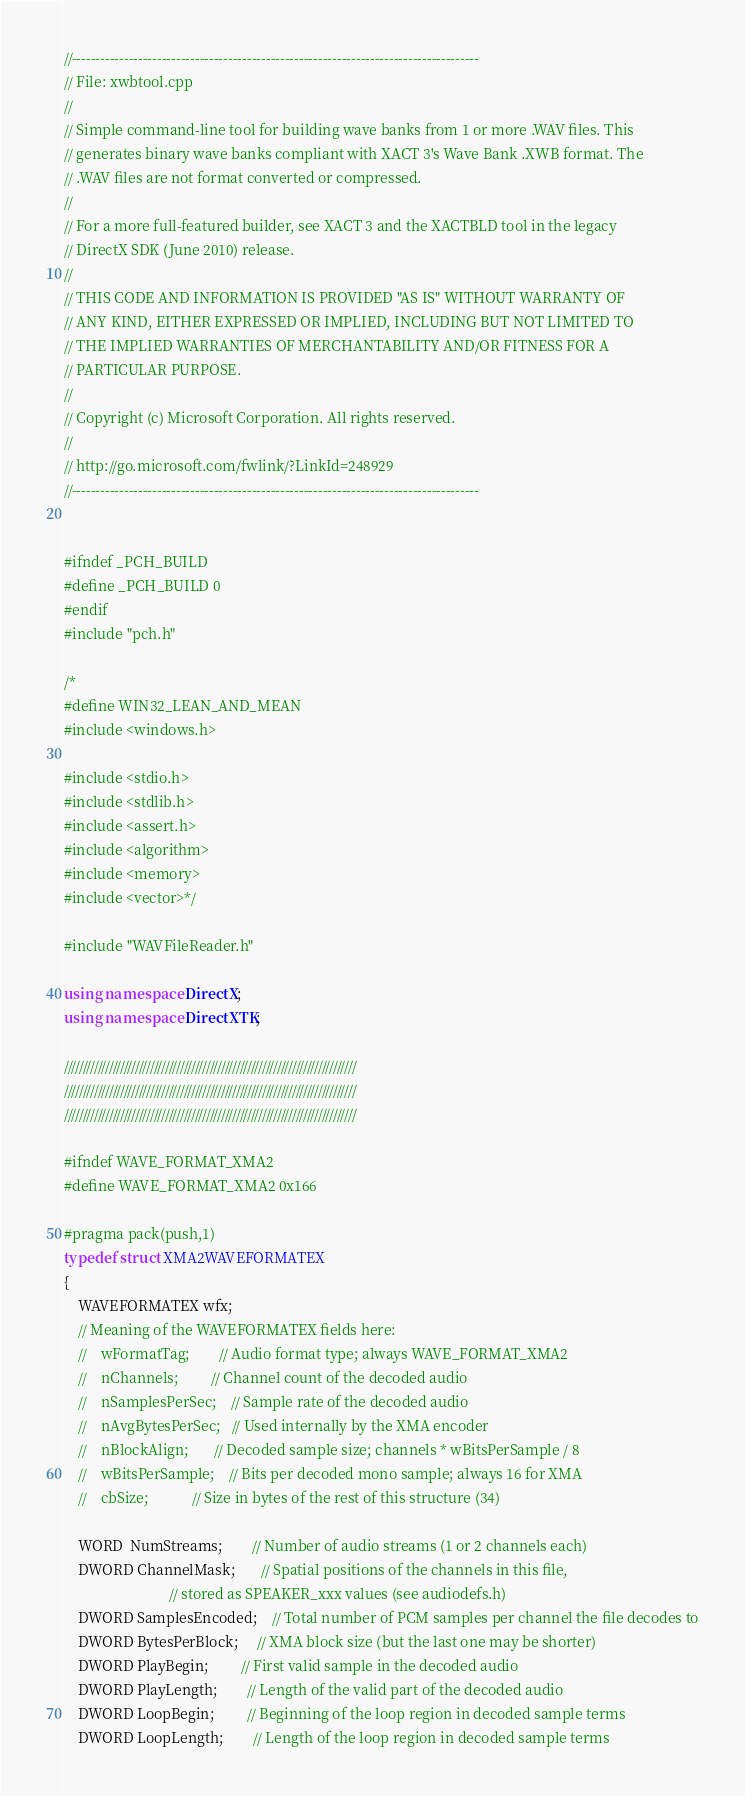Convert code to text. <code><loc_0><loc_0><loc_500><loc_500><_C++_>//--------------------------------------------------------------------------------------
// File: xwbtool.cpp
//
// Simple command-line tool for building wave banks from 1 or more .WAV files. This
// generates binary wave banks compliant with XACT 3's Wave Bank .XWB format. The
// .WAV files are not format converted or compressed.
//
// For a more full-featured builder, see XACT 3 and the XACTBLD tool in the legacy
// DirectX SDK (June 2010) release.
//
// THIS CODE AND INFORMATION IS PROVIDED "AS IS" WITHOUT WARRANTY OF
// ANY KIND, EITHER EXPRESSED OR IMPLIED, INCLUDING BUT NOT LIMITED TO
// THE IMPLIED WARRANTIES OF MERCHANTABILITY AND/OR FITNESS FOR A
// PARTICULAR PURPOSE.
//
// Copyright (c) Microsoft Corporation. All rights reserved.
//
// http://go.microsoft.com/fwlink/?LinkId=248929
//--------------------------------------------------------------------------------------


#ifndef _PCH_BUILD
#define _PCH_BUILD 0
#endif
#include "pch.h"

/*
#define WIN32_LEAN_AND_MEAN
#include <windows.h>

#include <stdio.h>
#include <stdlib.h>
#include <assert.h>
#include <algorithm>
#include <memory>
#include <vector>*/

#include "WAVFileReader.h"

using namespace DirectX;
using namespace DirectXTK;

//////////////////////////////////////////////////////////////////////////////
//////////////////////////////////////////////////////////////////////////////
//////////////////////////////////////////////////////////////////////////////

#ifndef WAVE_FORMAT_XMA2
#define WAVE_FORMAT_XMA2 0x166

#pragma pack(push,1)
typedef struct XMA2WAVEFORMATEX
{
    WAVEFORMATEX wfx;
    // Meaning of the WAVEFORMATEX fields here:
    //    wFormatTag;        // Audio format type; always WAVE_FORMAT_XMA2
    //    nChannels;         // Channel count of the decoded audio
    //    nSamplesPerSec;    // Sample rate of the decoded audio
    //    nAvgBytesPerSec;   // Used internally by the XMA encoder
    //    nBlockAlign;       // Decoded sample size; channels * wBitsPerSample / 8
    //    wBitsPerSample;    // Bits per decoded mono sample; always 16 for XMA
    //    cbSize;            // Size in bytes of the rest of this structure (34)

    WORD  NumStreams;        // Number of audio streams (1 or 2 channels each)
    DWORD ChannelMask;       // Spatial positions of the channels in this file,
                             // stored as SPEAKER_xxx values (see audiodefs.h)
    DWORD SamplesEncoded;    // Total number of PCM samples per channel the file decodes to
    DWORD BytesPerBlock;     // XMA block size (but the last one may be shorter)
    DWORD PlayBegin;         // First valid sample in the decoded audio
    DWORD PlayLength;        // Length of the valid part of the decoded audio
    DWORD LoopBegin;         // Beginning of the loop region in decoded sample terms
    DWORD LoopLength;        // Length of the loop region in decoded sample terms</code> 